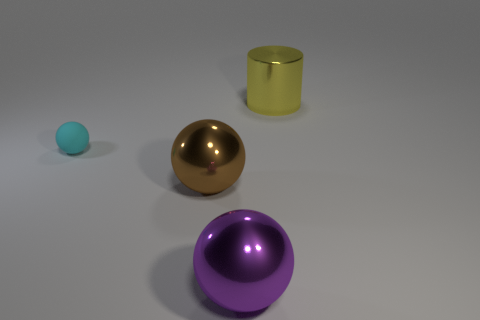Add 1 cyan matte spheres. How many objects exist? 5 Subtract all cylinders. How many objects are left? 3 Add 1 tiny matte things. How many tiny matte things are left? 2 Add 4 large brown metal spheres. How many large brown metal spheres exist? 5 Subtract 0 green cylinders. How many objects are left? 4 Subtract all big brown shiny things. Subtract all large brown spheres. How many objects are left? 2 